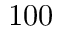Convert formula to latex. <formula><loc_0><loc_0><loc_500><loc_500>1 0 0</formula> 